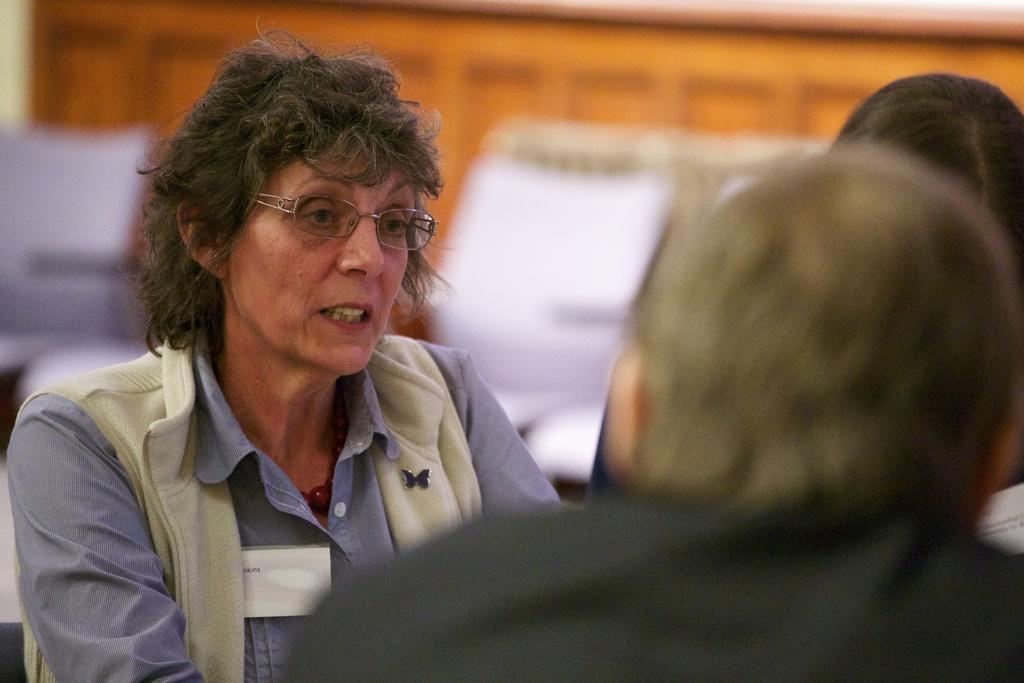In one or two sentences, can you explain what this image depicts? In this picture we can see three people and a woman wore spectacles and at the back of her we can see some objects and it is blur. 